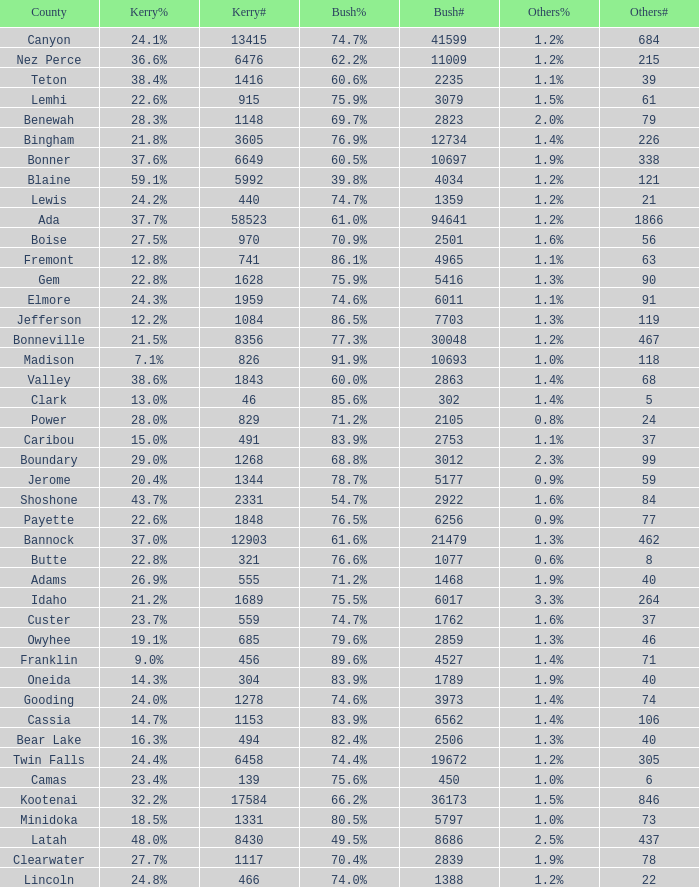What percentage of the votes were for others in the county where 462 people voted that way? 1.3%. 